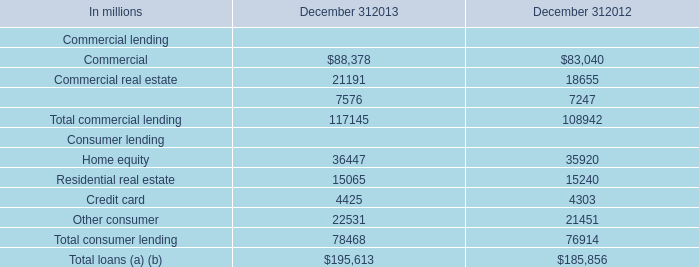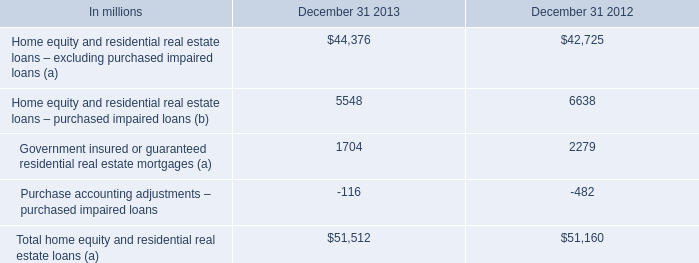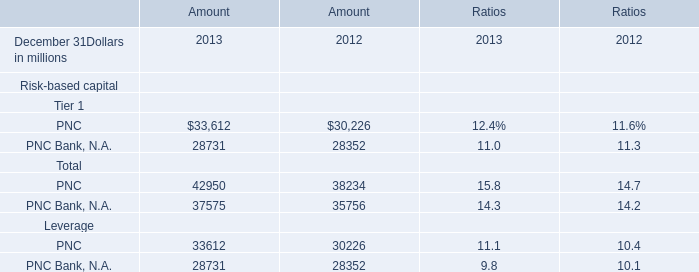What is the Amount for Risk-based capital Leverage:PNC Bank, N.A. in the year ended December 31 where the Amount for Risk-based capital Total:PNC Bank, N.A. is the lowest? (in million) 
Answer: 28352. 